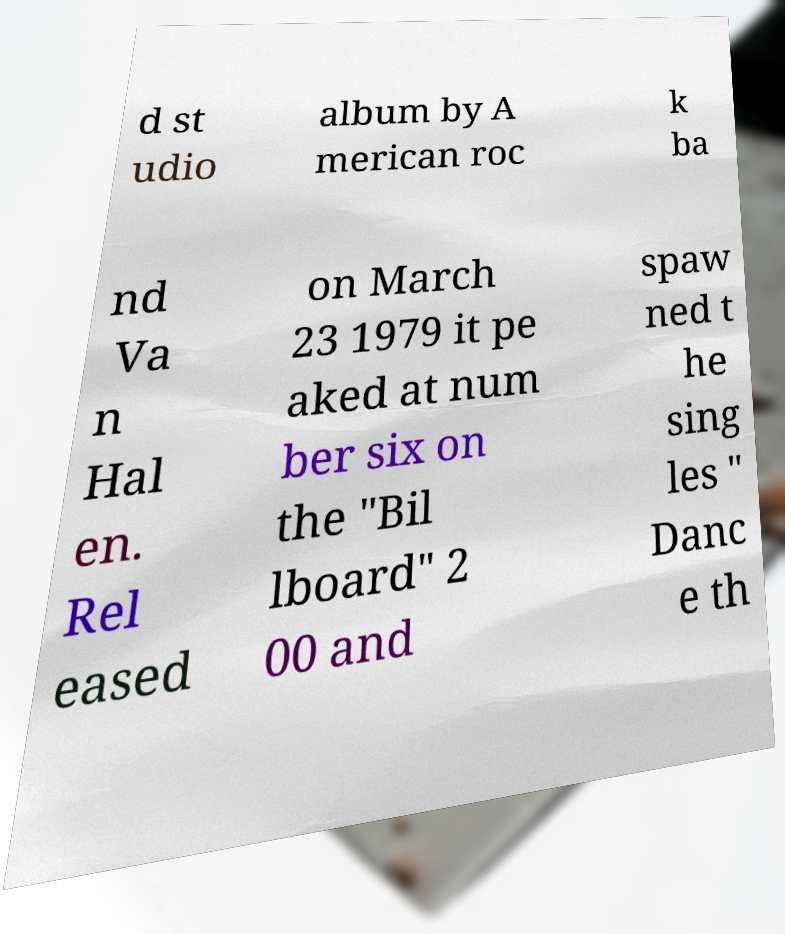For documentation purposes, I need the text within this image transcribed. Could you provide that? d st udio album by A merican roc k ba nd Va n Hal en. Rel eased on March 23 1979 it pe aked at num ber six on the "Bil lboard" 2 00 and spaw ned t he sing les " Danc e th 